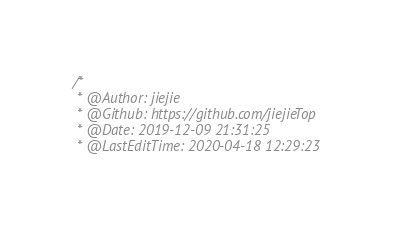<code> <loc_0><loc_0><loc_500><loc_500><_C_>/*
 * @Author: jiejie
 * @Github: https://github.com/jiejieTop
 * @Date: 2019-12-09 21:31:25
 * @LastEditTime: 2020-04-18 12:29:23</code> 